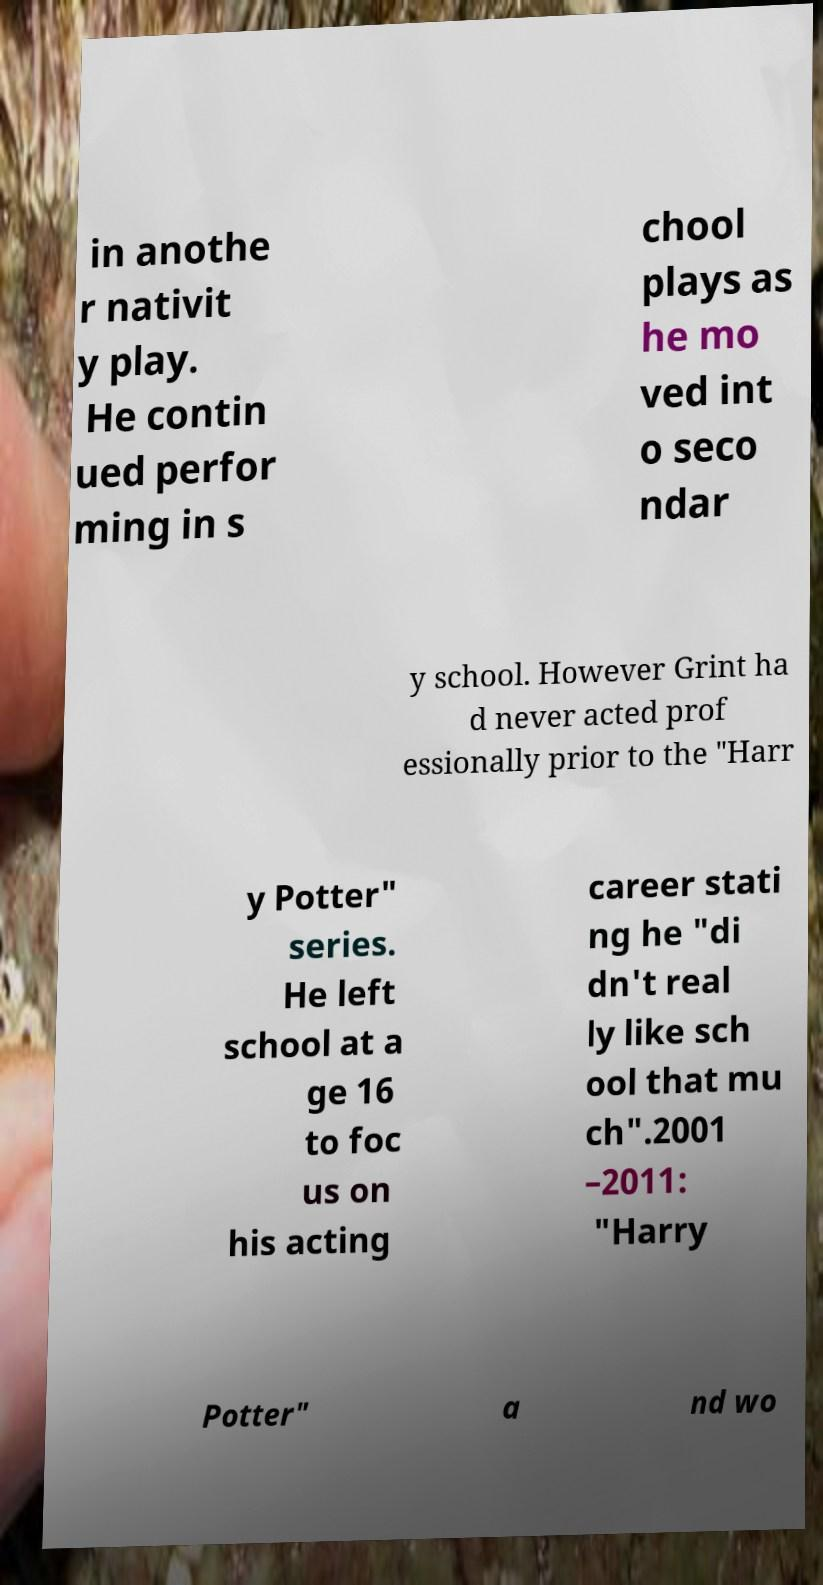I need the written content from this picture converted into text. Can you do that? in anothe r nativit y play. He contin ued perfor ming in s chool plays as he mo ved int o seco ndar y school. However Grint ha d never acted prof essionally prior to the "Harr y Potter" series. He left school at a ge 16 to foc us on his acting career stati ng he "di dn't real ly like sch ool that mu ch".2001 –2011: "Harry Potter" a nd wo 